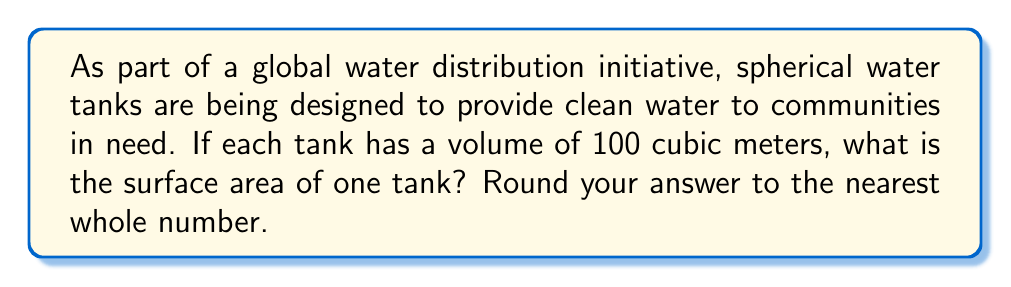Teach me how to tackle this problem. To solve this problem, we'll follow these steps:

1) The volume of a sphere is given by the formula:
   $$V = \frac{4}{3}\pi r^3$$
   where $V$ is the volume and $r$ is the radius.

2) We're given that $V = 100$ m³. Let's substitute this into the formula:
   $$100 = \frac{4}{3}\pi r^3$$

3) Now, let's solve for $r$:
   $$r^3 = \frac{100 \cdot 3}{4\pi}$$
   $$r^3 = \frac{75}{\pi}$$
   $$r = \sqrt[3]{\frac{75}{\pi}}$$

4) Using a calculator, we find that $r \approx 2.8794$ m.

5) The surface area of a sphere is given by the formula:
   $$A = 4\pi r^2$$

6) Let's substitute our value for $r$:
   $$A = 4\pi (2.8794)^2$$
   $$A \approx 104.1871$$ m²

7) Rounding to the nearest whole number, we get 104 m².
Answer: 104 m² 